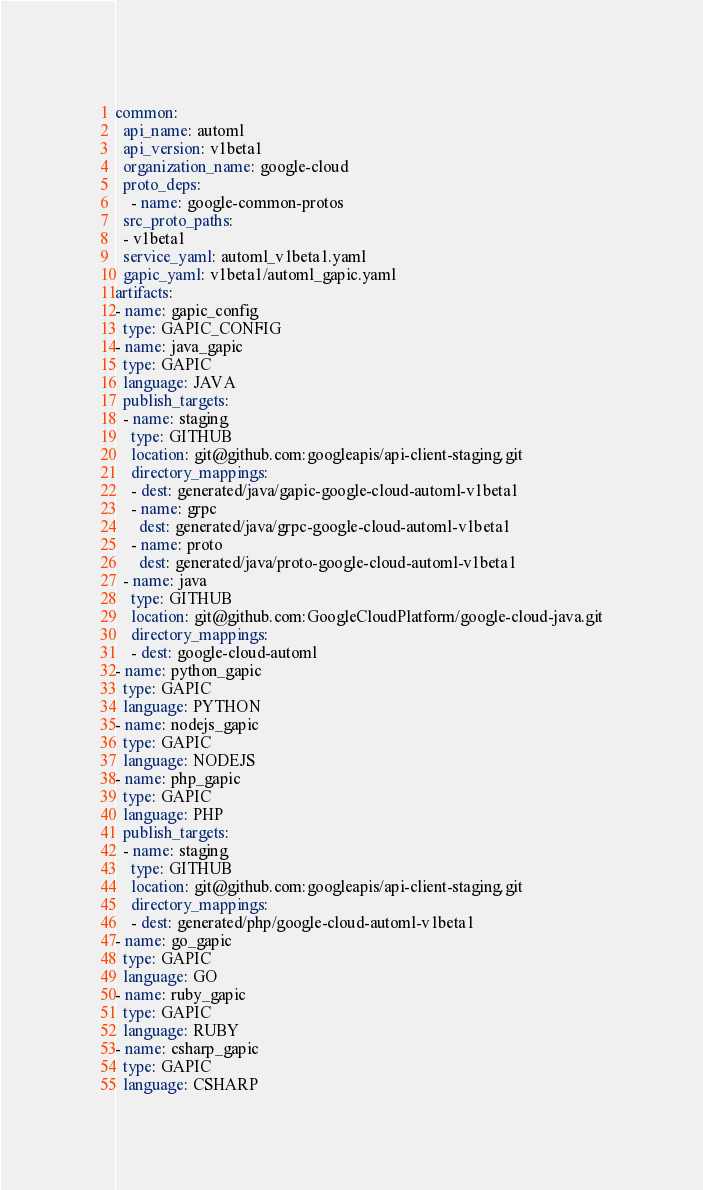<code> <loc_0><loc_0><loc_500><loc_500><_YAML_>common:
  api_name: automl
  api_version: v1beta1
  organization_name: google-cloud
  proto_deps:
    - name: google-common-protos
  src_proto_paths:
  - v1beta1
  service_yaml: automl_v1beta1.yaml
  gapic_yaml: v1beta1/automl_gapic.yaml
artifacts:
- name: gapic_config
  type: GAPIC_CONFIG
- name: java_gapic
  type: GAPIC
  language: JAVA
  publish_targets:
  - name: staging
    type: GITHUB
    location: git@github.com:googleapis/api-client-staging.git
    directory_mappings:
    - dest: generated/java/gapic-google-cloud-automl-v1beta1
    - name: grpc
      dest: generated/java/grpc-google-cloud-automl-v1beta1
    - name: proto
      dest: generated/java/proto-google-cloud-automl-v1beta1
  - name: java
    type: GITHUB
    location: git@github.com:GoogleCloudPlatform/google-cloud-java.git
    directory_mappings:
    - dest: google-cloud-automl
- name: python_gapic
  type: GAPIC
  language: PYTHON
- name: nodejs_gapic
  type: GAPIC
  language: NODEJS
- name: php_gapic
  type: GAPIC
  language: PHP
  publish_targets:
  - name: staging
    type: GITHUB
    location: git@github.com:googleapis/api-client-staging.git
    directory_mappings:
    - dest: generated/php/google-cloud-automl-v1beta1
- name: go_gapic
  type: GAPIC
  language: GO
- name: ruby_gapic
  type: GAPIC
  language: RUBY
- name: csharp_gapic
  type: GAPIC
  language: CSHARP
</code> 